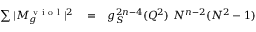Convert formula to latex. <formula><loc_0><loc_0><loc_500><loc_500>\begin{array} { r l r } { \sum | M _ { g } ^ { v i o l } | ^ { 2 } } & = } & { g _ { S } ^ { 2 n - 4 } ( Q ^ { 2 } ) N ^ { n - 2 } ( N ^ { 2 } - 1 ) } \end{array}</formula> 